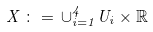<formula> <loc_0><loc_0><loc_500><loc_500>X \, \colon = \, \cup _ { i = 1 } ^ { 4 } U _ { i } \times \mathbb { R }</formula> 